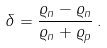<formula> <loc_0><loc_0><loc_500><loc_500>\delta = \frac { \varrho _ { n } - \varrho _ { n } } { \varrho _ { n } + \varrho _ { p } } \, .</formula> 